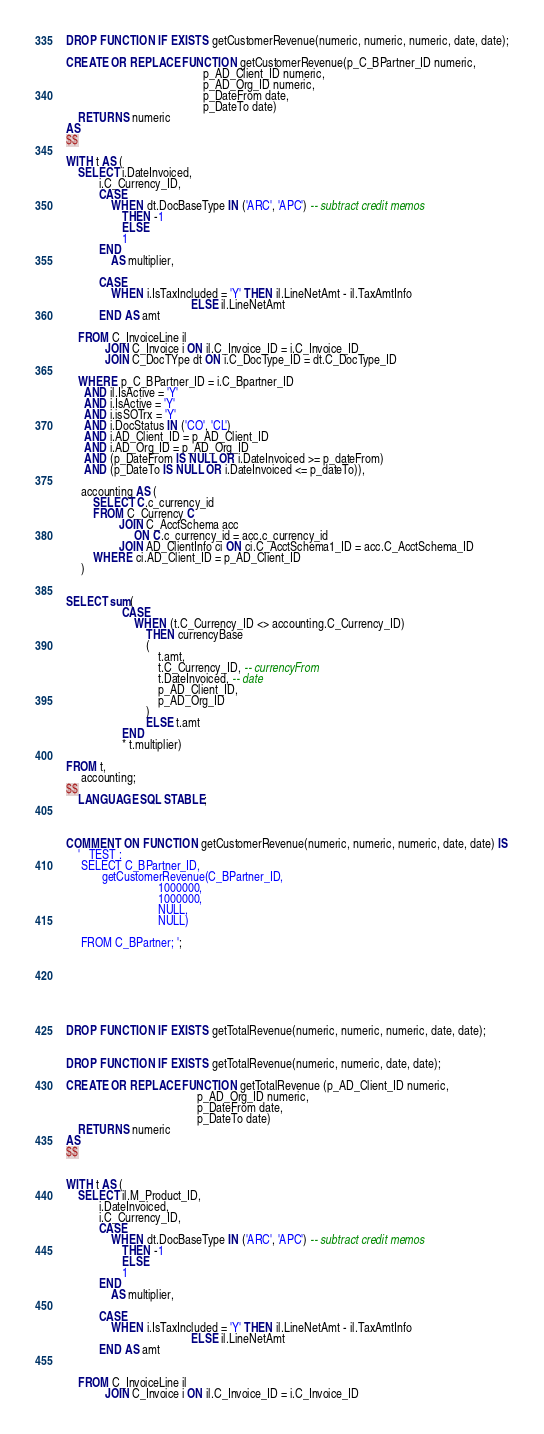<code> <loc_0><loc_0><loc_500><loc_500><_SQL_>DROP FUNCTION IF EXISTS getCustomerRevenue(numeric, numeric, numeric, date, date);

CREATE OR REPLACE FUNCTION getCustomerRevenue(p_C_BPartner_ID numeric,
                                              p_AD_Client_ID numeric,
                                              p_AD_Org_ID numeric,
                                              p_DateFrom date,
                                              p_DateTo date)
    RETURNS numeric
AS
$$

WITH t AS (
    SELECT i.DateInvoiced,
           i.C_Currency_ID,
           CASE
               WHEN dt.DocBaseType IN ('ARC', 'APC') -- subtract credit memos
                   THEN -1
                   ELSE
                   1
           END
               AS multiplier,

           CASE
               WHEN i.IsTaxIncluded = 'Y' THEN il.LineNetAmt - il.TaxAmtInfo
                                          ELSE il.LineNetAmt
           END AS amt

    FROM C_InvoiceLine il
             JOIN C_Invoice i ON il.C_Invoice_ID = i.C_Invoice_ID
             JOIN C_DocTYpe dt ON i.C_DocType_ID = dt.C_DocType_ID

    WHERE p_C_BPartner_ID = i.C_Bpartner_ID
      AND il.IsActive = 'Y'
      AND i.IsActive = 'Y'
      AND i.isSOTrx = 'Y'
      AND i.DocStatus IN ('CO', 'CL')
      AND i.AD_Client_ID = p_AD_Client_ID
      AND i.AD_Org_ID = p_AD_Org_ID
      AND (p_DateFrom IS NULL OR i.DateInvoiced >= p_dateFrom)
      AND (p_DateTo IS NULL OR i.DateInvoiced <= p_dateTo)),

     accounting AS (
         SELECT C.c_currency_id
         FROM C_Currency C
                  JOIN C_AcctSchema acc
                       ON C.c_currency_id = acc.c_currency_id
                  JOIN AD_ClientInfo ci ON ci.C_AcctSchema1_ID = acc.C_AcctSchema_ID
         WHERE ci.AD_Client_ID = p_AD_Client_ID
     )


SELECT sum(
                   CASE
                       WHEN (t.C_Currency_ID <> accounting.C_Currency_ID)
                           THEN currencyBase
                           (
                               t.amt,
                               t.C_Currency_ID, -- currencyFrom
                               t.DateInvoiced, -- date
                               p_AD_Client_ID,
                               p_AD_Org_ID
                           )
                           ELSE t.amt
                   END
                   * t.multiplier)

FROM t,
     accounting;
$$
    LANGUAGE SQL STABLE;



COMMENT ON FUNCTION getCustomerRevenue(numeric, numeric, numeric, date, date) IS
    '   TEST :
     SELECT C_BPartner_ID,
            getCustomerRevenue(C_BPartner_ID,
                               1000000,
                               1000000,
                               NULL,
                               NULL)

     FROM C_BPartner; ';







DROP FUNCTION IF EXISTS getTotalRevenue(numeric, numeric, numeric, date, date);


DROP FUNCTION IF EXISTS getTotalRevenue(numeric, numeric, date, date);

CREATE OR REPLACE FUNCTION getTotalRevenue (p_AD_Client_ID numeric,
                                            p_AD_Org_ID numeric,
                                            p_DateFrom date,
                                            p_DateTo date)
    RETURNS numeric
AS
$$


WITH t AS (
    SELECT il.M_Product_ID,
           i.DateInvoiced,
           i.C_Currency_ID,
           CASE
               WHEN dt.DocBaseType IN ('ARC', 'APC') -- subtract credit memos
                   THEN -1
                   ELSE
                   1
           END
               AS multiplier,

           CASE
               WHEN i.IsTaxIncluded = 'Y' THEN il.LineNetAmt - il.TaxAmtInfo
                                          ELSE il.LineNetAmt
           END AS amt


    FROM C_InvoiceLine il
             JOIN C_Invoice i ON il.C_Invoice_ID = i.C_Invoice_ID</code> 